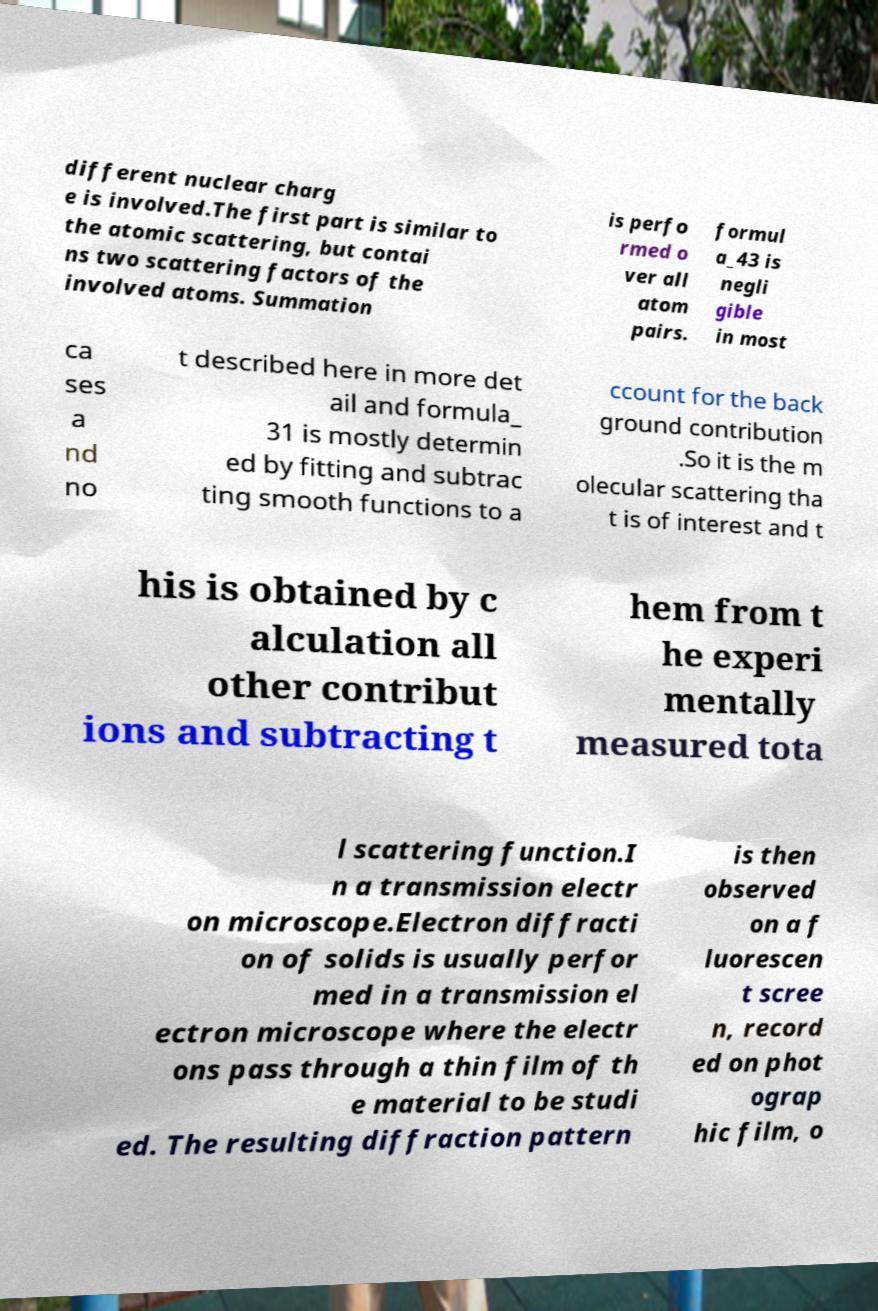What messages or text are displayed in this image? I need them in a readable, typed format. different nuclear charg e is involved.The first part is similar to the atomic scattering, but contai ns two scattering factors of the involved atoms. Summation is perfo rmed o ver all atom pairs. formul a_43 is negli gible in most ca ses a nd no t described here in more det ail and formula_ 31 is mostly determin ed by fitting and subtrac ting smooth functions to a ccount for the back ground contribution .So it is the m olecular scattering tha t is of interest and t his is obtained by c alculation all other contribut ions and subtracting t hem from t he experi mentally measured tota l scattering function.I n a transmission electr on microscope.Electron diffracti on of solids is usually perfor med in a transmission el ectron microscope where the electr ons pass through a thin film of th e material to be studi ed. The resulting diffraction pattern is then observed on a f luorescen t scree n, record ed on phot ograp hic film, o 